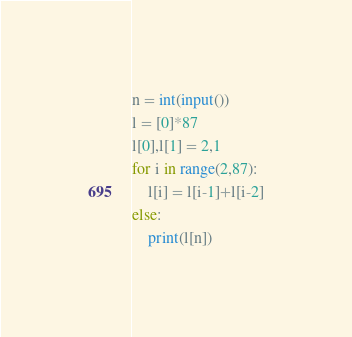Convert code to text. <code><loc_0><loc_0><loc_500><loc_500><_Python_>n = int(input())
l = [0]*87
l[0],l[1] = 2,1
for i in range(2,87):
    l[i] = l[i-1]+l[i-2]
else:    
    print(l[n])</code> 